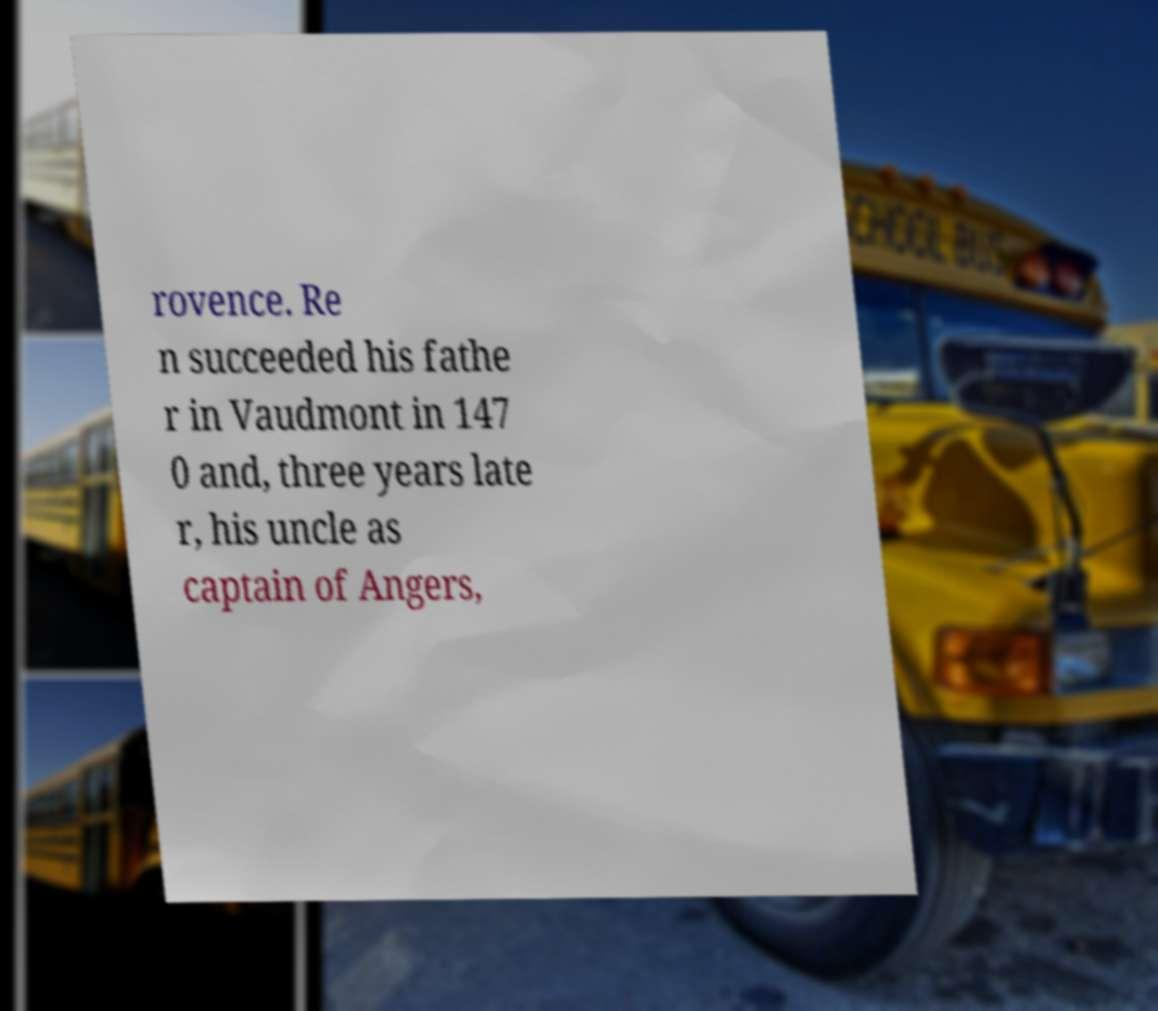I need the written content from this picture converted into text. Can you do that? rovence. Re n succeeded his fathe r in Vaudmont in 147 0 and, three years late r, his uncle as captain of Angers, 